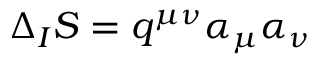<formula> <loc_0><loc_0><loc_500><loc_500>\Delta _ { I } S = q ^ { \mu \nu } \alpha _ { \mu } \alpha _ { \nu }</formula> 